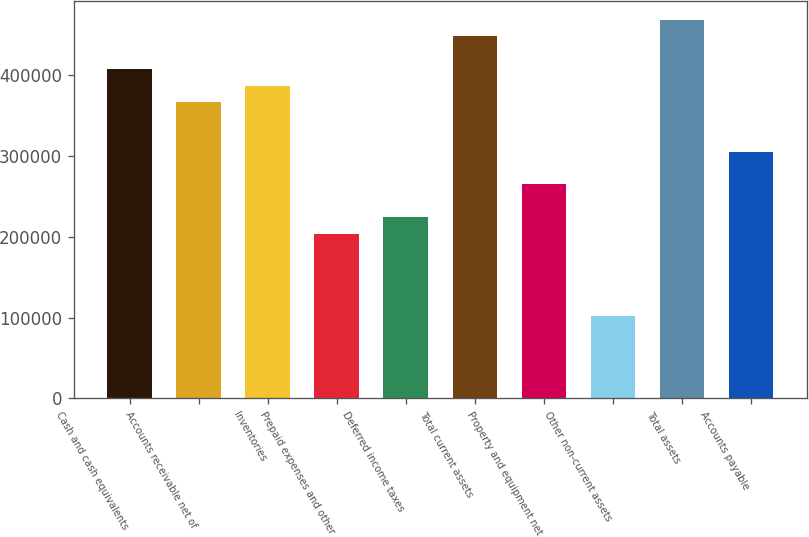<chart> <loc_0><loc_0><loc_500><loc_500><bar_chart><fcel>Cash and cash equivalents<fcel>Accounts receivable net of<fcel>Inventories<fcel>Prepaid expenses and other<fcel>Deferred income taxes<fcel>Total current assets<fcel>Property and equipment net<fcel>Other non-current assets<fcel>Total assets<fcel>Accounts payable<nl><fcel>407371<fcel>366634<fcel>387003<fcel>203687<fcel>224055<fcel>448108<fcel>264792<fcel>101845<fcel>468476<fcel>305529<nl></chart> 